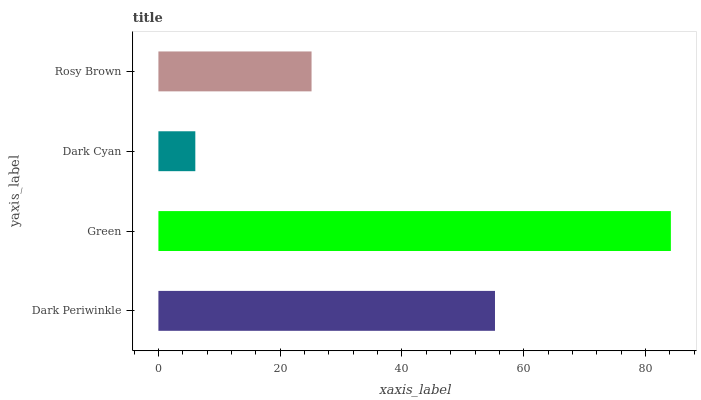Is Dark Cyan the minimum?
Answer yes or no. Yes. Is Green the maximum?
Answer yes or no. Yes. Is Green the minimum?
Answer yes or no. No. Is Dark Cyan the maximum?
Answer yes or no. No. Is Green greater than Dark Cyan?
Answer yes or no. Yes. Is Dark Cyan less than Green?
Answer yes or no. Yes. Is Dark Cyan greater than Green?
Answer yes or no. No. Is Green less than Dark Cyan?
Answer yes or no. No. Is Dark Periwinkle the high median?
Answer yes or no. Yes. Is Rosy Brown the low median?
Answer yes or no. Yes. Is Dark Cyan the high median?
Answer yes or no. No. Is Green the low median?
Answer yes or no. No. 